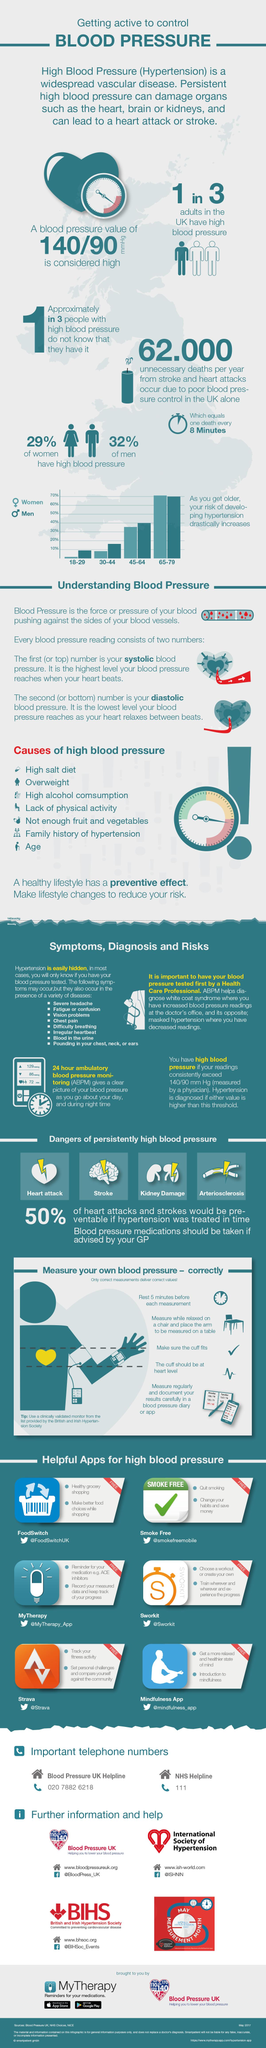Identify some key points in this picture. High blood pressure can lead to several dangerous conditions, including heart attack, stroke, kidney damage, and diabetes. These conditions are a result of persistently high blood pressure and can have serious consequences if left untreated. It is important to be aware of the symptoms of hypertension, specifically blood in the urine and vision problems, as they are indicative of this condition. In the age group of 18 to 29, men have a higher risk of developing hypertension. I am seeking the name of an app that reminds patients to take their medication at the appropriate time. The app is called MyTherapy. There are six applications available that assist people with managing high blood pressure. 